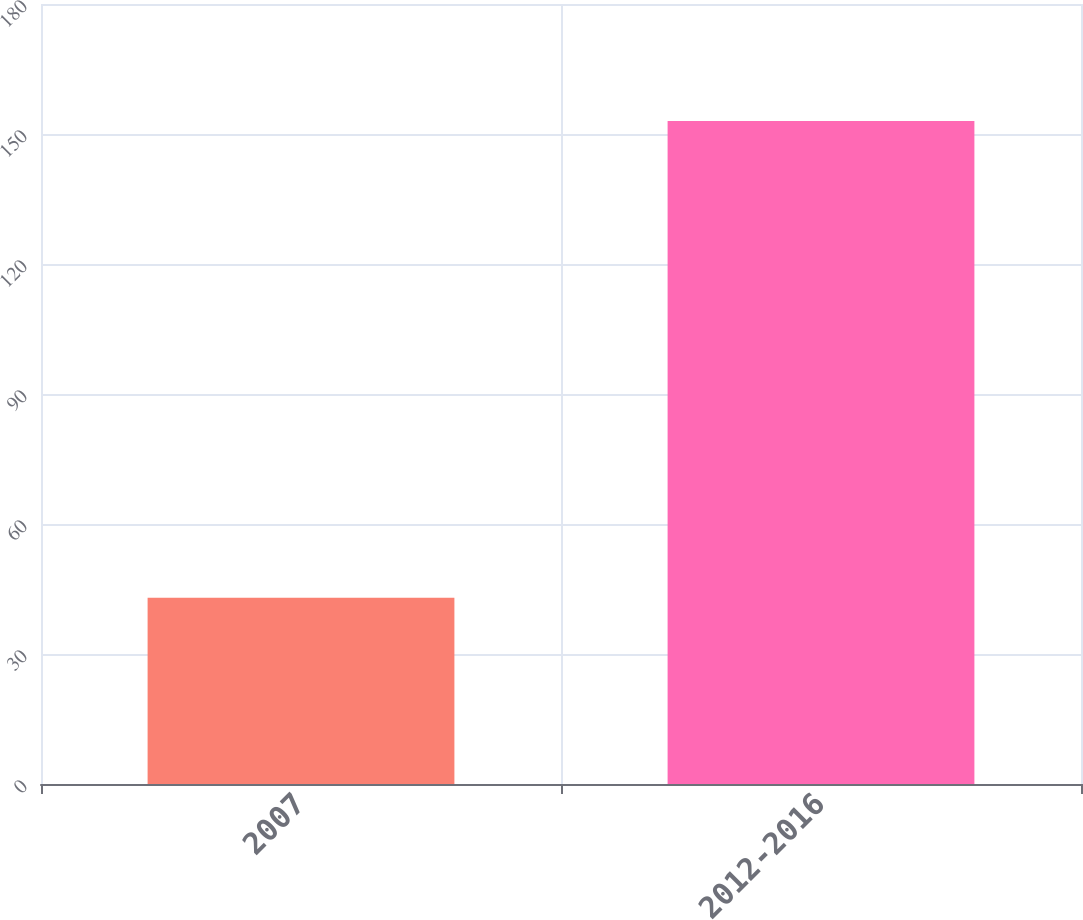<chart> <loc_0><loc_0><loc_500><loc_500><bar_chart><fcel>2007<fcel>2012-2016<nl><fcel>43<fcel>153<nl></chart> 